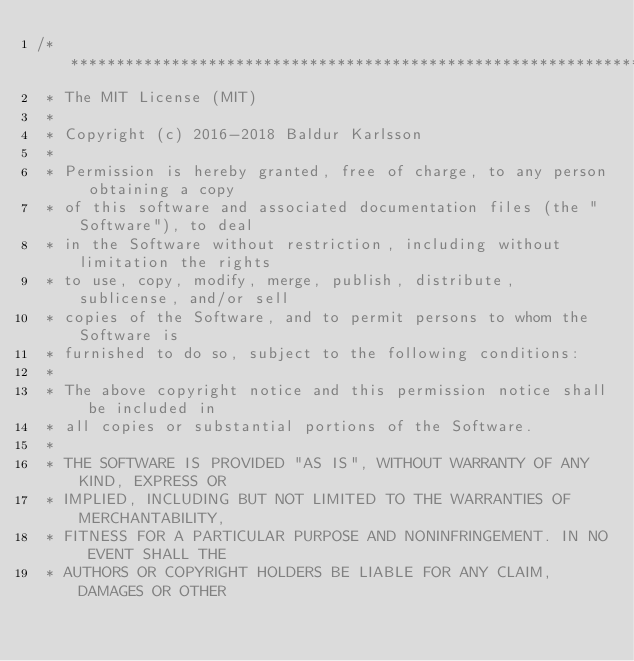Convert code to text. <code><loc_0><loc_0><loc_500><loc_500><_C_>/******************************************************************************
 * The MIT License (MIT)
 *
 * Copyright (c) 2016-2018 Baldur Karlsson
 *
 * Permission is hereby granted, free of charge, to any person obtaining a copy
 * of this software and associated documentation files (the "Software"), to deal
 * in the Software without restriction, including without limitation the rights
 * to use, copy, modify, merge, publish, distribute, sublicense, and/or sell
 * copies of the Software, and to permit persons to whom the Software is
 * furnished to do so, subject to the following conditions:
 *
 * The above copyright notice and this permission notice shall be included in
 * all copies or substantial portions of the Software.
 *
 * THE SOFTWARE IS PROVIDED "AS IS", WITHOUT WARRANTY OF ANY KIND, EXPRESS OR
 * IMPLIED, INCLUDING BUT NOT LIMITED TO THE WARRANTIES OF MERCHANTABILITY,
 * FITNESS FOR A PARTICULAR PURPOSE AND NONINFRINGEMENT. IN NO EVENT SHALL THE
 * AUTHORS OR COPYRIGHT HOLDERS BE LIABLE FOR ANY CLAIM, DAMAGES OR OTHER</code> 